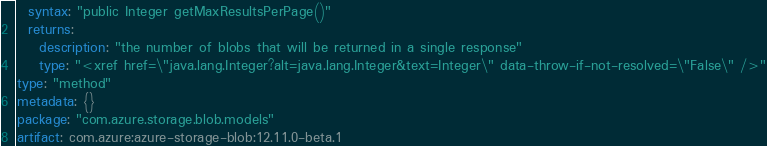Convert code to text. <code><loc_0><loc_0><loc_500><loc_500><_YAML_>  syntax: "public Integer getMaxResultsPerPage()"
  returns:
    description: "the number of blobs that will be returned in a single response"
    type: "<xref href=\"java.lang.Integer?alt=java.lang.Integer&text=Integer\" data-throw-if-not-resolved=\"False\" />"
type: "method"
metadata: {}
package: "com.azure.storage.blob.models"
artifact: com.azure:azure-storage-blob:12.11.0-beta.1
</code> 